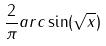<formula> <loc_0><loc_0><loc_500><loc_500>\frac { 2 } { \pi } a r c \sin ( \sqrt { x } )</formula> 